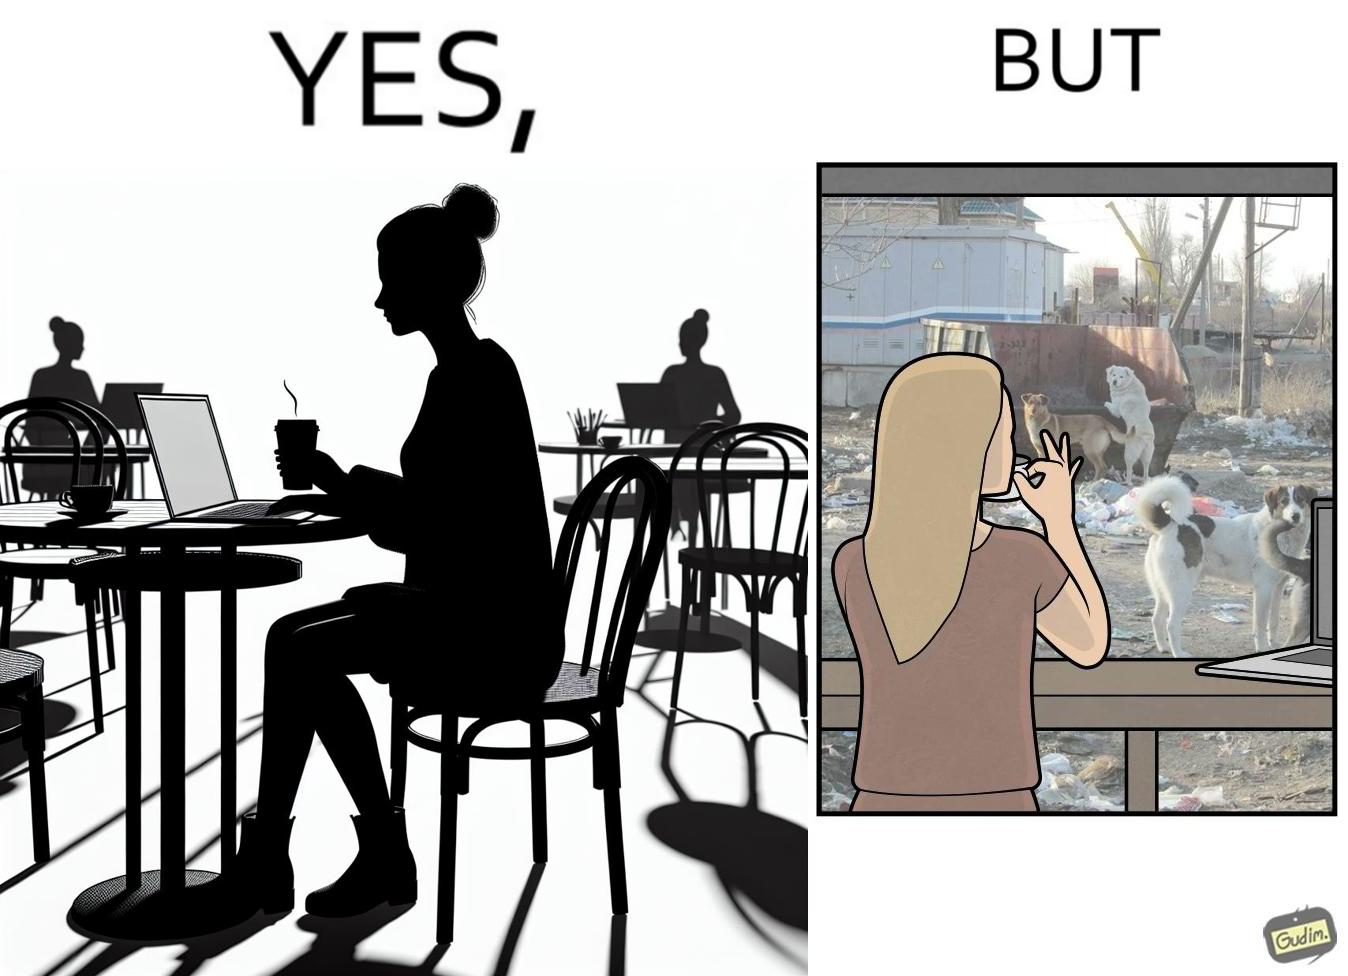What do you see in each half of this image? In the left part of the image: a woman having a cup of some hot beverage at some cafe with probably doing some work in the laptop In the right part of the image: a woman looking outside the window at the stray animals, who are probably in search of some food near the garbage bin 